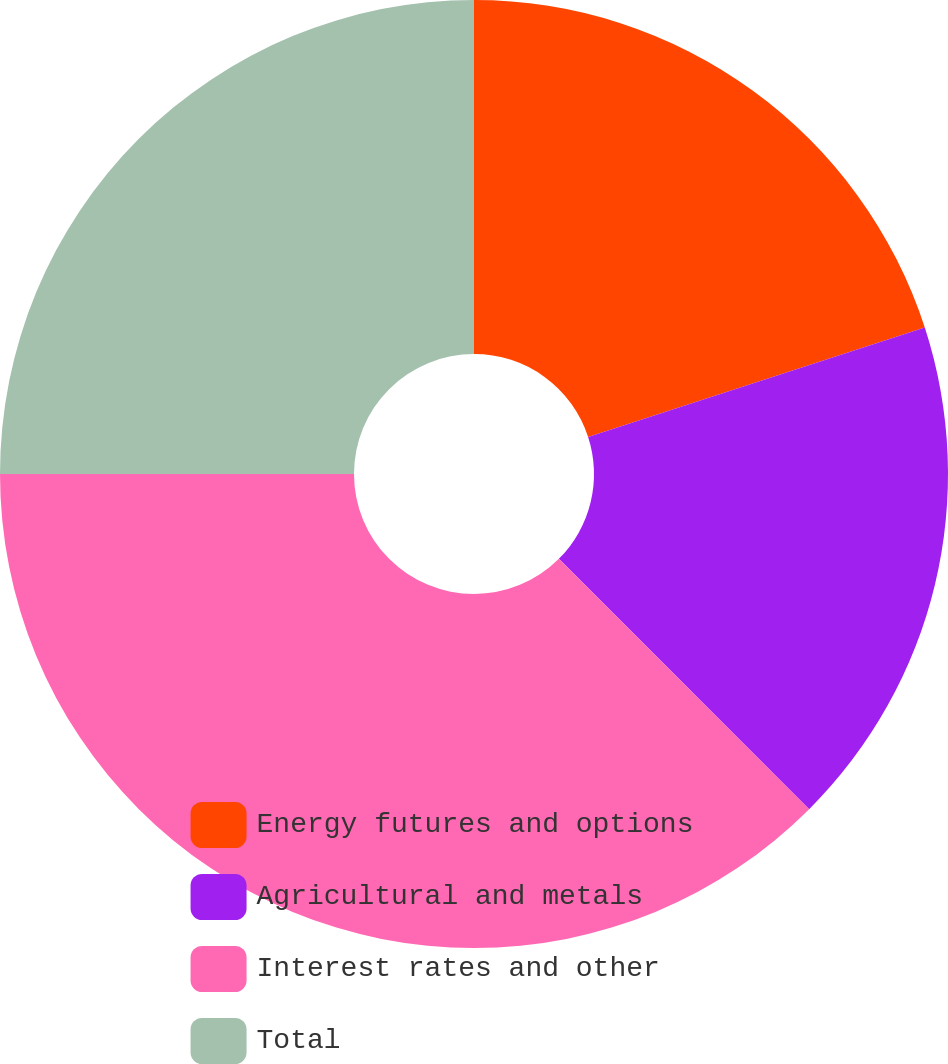<chart> <loc_0><loc_0><loc_500><loc_500><pie_chart><fcel>Energy futures and options<fcel>Agricultural and metals<fcel>Interest rates and other<fcel>Total<nl><fcel>20.0%<fcel>17.5%<fcel>37.5%<fcel>25.0%<nl></chart> 